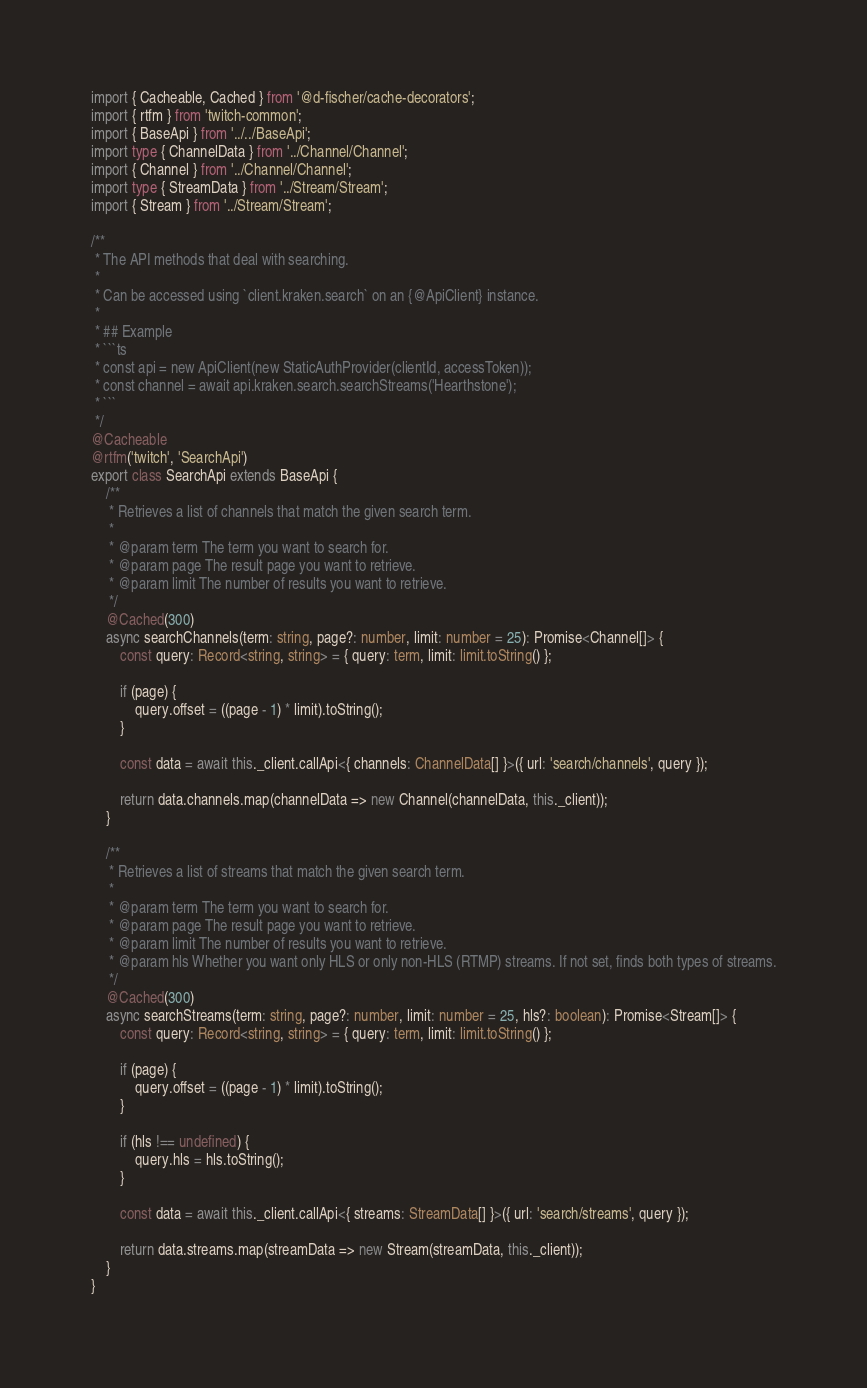Convert code to text. <code><loc_0><loc_0><loc_500><loc_500><_TypeScript_>import { Cacheable, Cached } from '@d-fischer/cache-decorators';
import { rtfm } from 'twitch-common';
import { BaseApi } from '../../BaseApi';
import type { ChannelData } from '../Channel/Channel';
import { Channel } from '../Channel/Channel';
import type { StreamData } from '../Stream/Stream';
import { Stream } from '../Stream/Stream';

/**
 * The API methods that deal with searching.
 *
 * Can be accessed using `client.kraken.search` on an {@ApiClient} instance.
 *
 * ## Example
 * ```ts
 * const api = new ApiClient(new StaticAuthProvider(clientId, accessToken));
 * const channel = await api.kraken.search.searchStreams('Hearthstone');
 * ```
 */
@Cacheable
@rtfm('twitch', 'SearchApi')
export class SearchApi extends BaseApi {
	/**
	 * Retrieves a list of channels that match the given search term.
	 *
	 * @param term The term you want to search for.
	 * @param page The result page you want to retrieve.
	 * @param limit The number of results you want to retrieve.
	 */
	@Cached(300)
	async searchChannels(term: string, page?: number, limit: number = 25): Promise<Channel[]> {
		const query: Record<string, string> = { query: term, limit: limit.toString() };

		if (page) {
			query.offset = ((page - 1) * limit).toString();
		}

		const data = await this._client.callApi<{ channels: ChannelData[] }>({ url: 'search/channels', query });

		return data.channels.map(channelData => new Channel(channelData, this._client));
	}

	/**
	 * Retrieves a list of streams that match the given search term.
	 *
	 * @param term The term you want to search for.
	 * @param page The result page you want to retrieve.
	 * @param limit The number of results you want to retrieve.
	 * @param hls Whether you want only HLS or only non-HLS (RTMP) streams. If not set, finds both types of streams.
	 */
	@Cached(300)
	async searchStreams(term: string, page?: number, limit: number = 25, hls?: boolean): Promise<Stream[]> {
		const query: Record<string, string> = { query: term, limit: limit.toString() };

		if (page) {
			query.offset = ((page - 1) * limit).toString();
		}

		if (hls !== undefined) {
			query.hls = hls.toString();
		}

		const data = await this._client.callApi<{ streams: StreamData[] }>({ url: 'search/streams', query });

		return data.streams.map(streamData => new Stream(streamData, this._client));
	}
}
</code> 